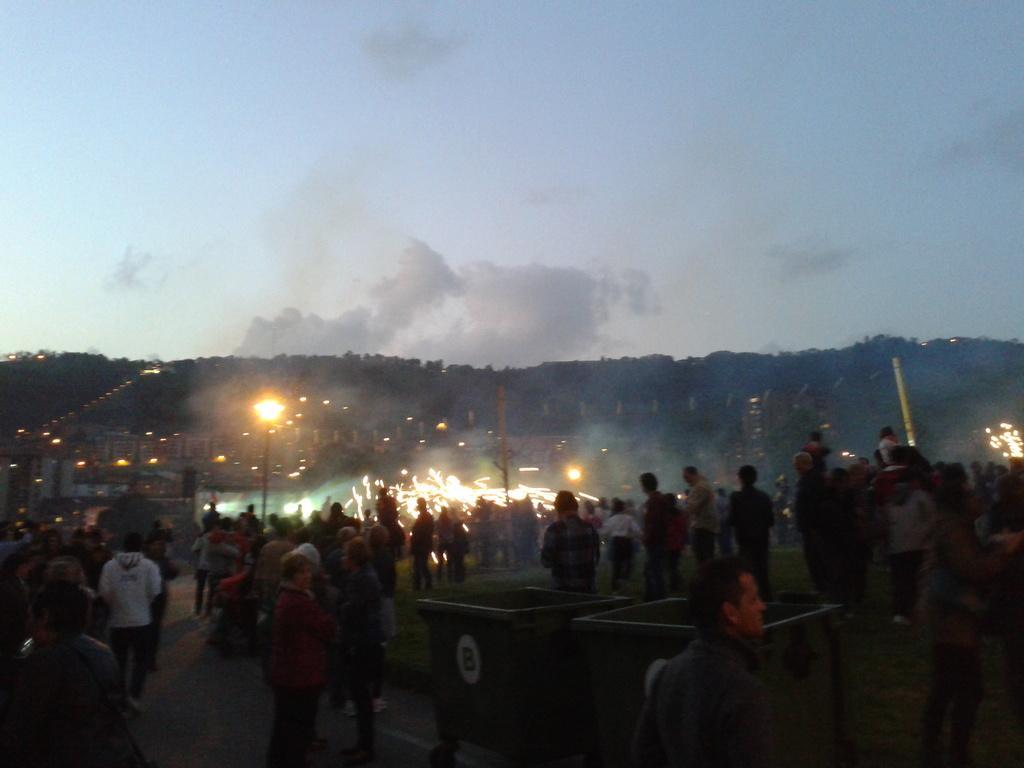Please provide a concise description of this image. There are groups of people standing. This is a street light. I think these are the dustbins. I can see the trees. These are the buildings with lights. I can see the clouds in the sky. 